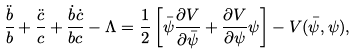<formula> <loc_0><loc_0><loc_500><loc_500>\frac { \ddot { b } } { b } + \frac { \ddot { c } } { c } + \frac { \dot { b } \dot { c } } { b c } - \Lambda = \frac { 1 } { 2 } \left [ \bar { \psi } \frac { \partial V } { \partial \bar { \psi } } + \frac { \partial V } { \partial \psi } \psi \right ] - V ( \bar { \psi } , \psi ) ,</formula> 